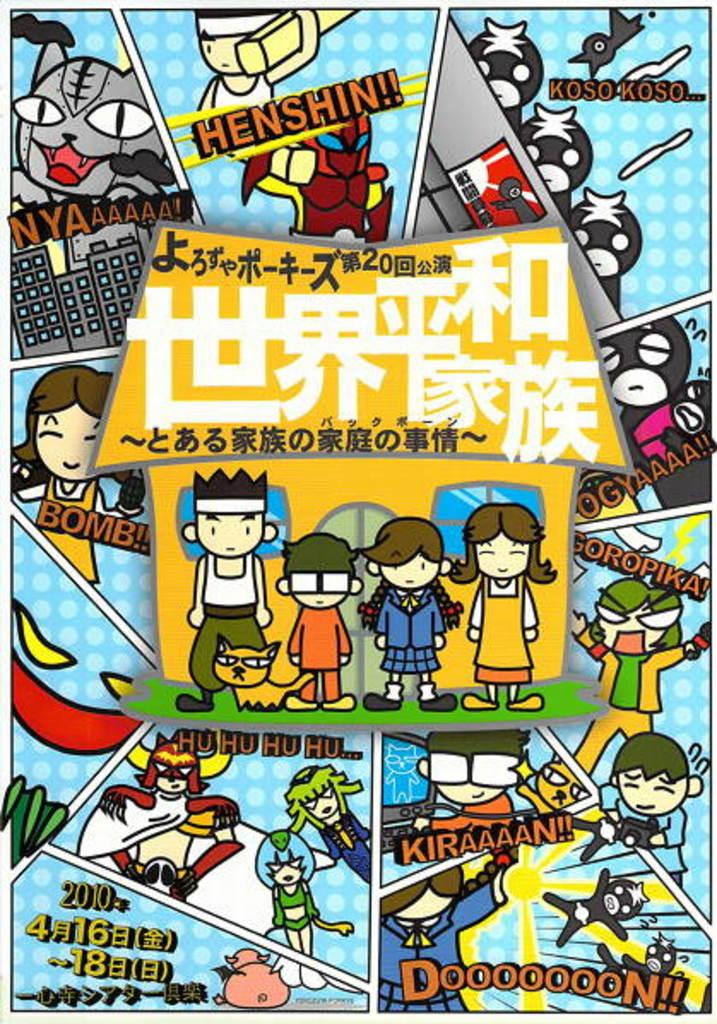<image>
Write a terse but informative summary of the picture. An anime cartoon has a lot of chinese writing but also santa is going ho ho ho. 